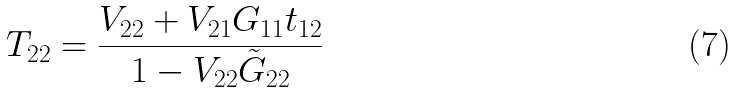<formula> <loc_0><loc_0><loc_500><loc_500>T _ { 2 2 } = \frac { V _ { 2 2 } + V _ { 2 1 } G _ { 1 1 } t _ { 1 2 } } { 1 - V _ { 2 2 } \tilde { G } _ { 2 2 } }</formula> 